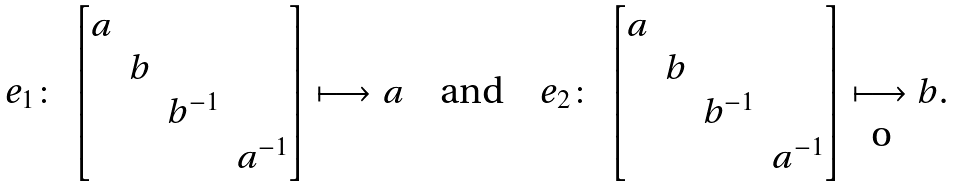Convert formula to latex. <formula><loc_0><loc_0><loc_500><loc_500>e _ { 1 } \colon \, \begin{bmatrix} a \\ & b \\ & & b ^ { - 1 } \\ & & & a ^ { - 1 } \end{bmatrix} \longmapsto a \quad \text {and} \quad e _ { 2 } \colon \, \begin{bmatrix} a \\ & b \\ & & b ^ { - 1 } \\ & & & a ^ { - 1 } \end{bmatrix} \longmapsto b .</formula> 